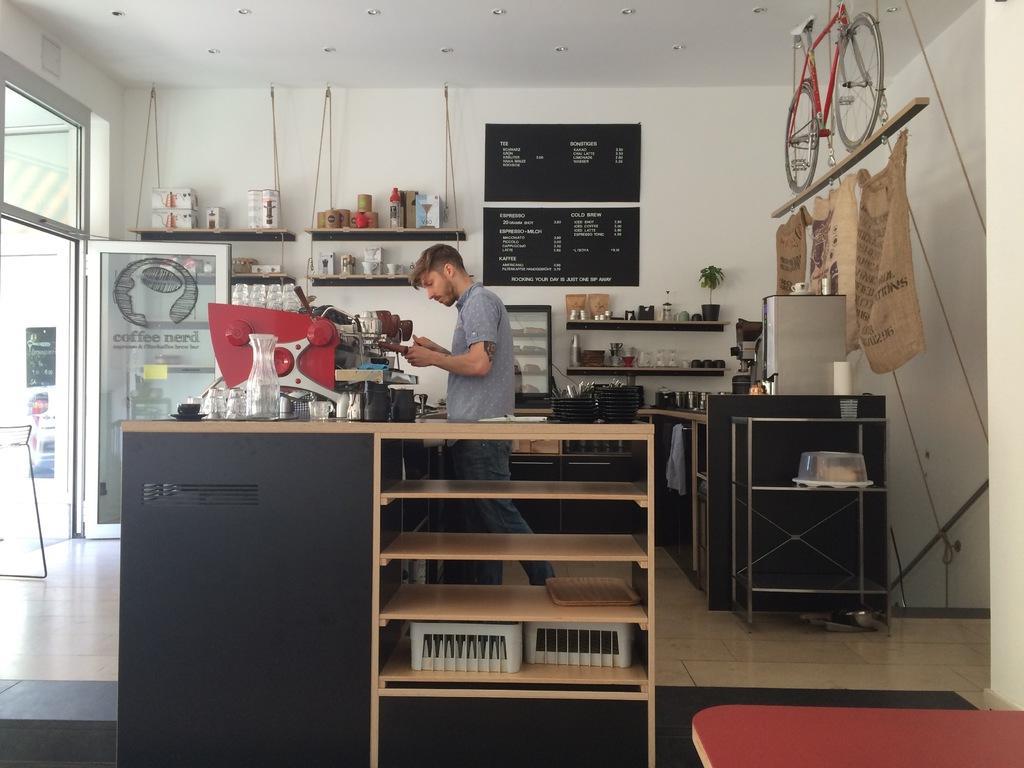Describe this image in one or two sentences. In this image, we can see a person standing. We can see a table with some shelves and objects in it. We can also see the wall. We can see a bicycle and the door. We can also see some posters with text. We can see the ground. We can see a red colored object in the bottom right corner. We can also see some shelves with objects and some posters with text. 